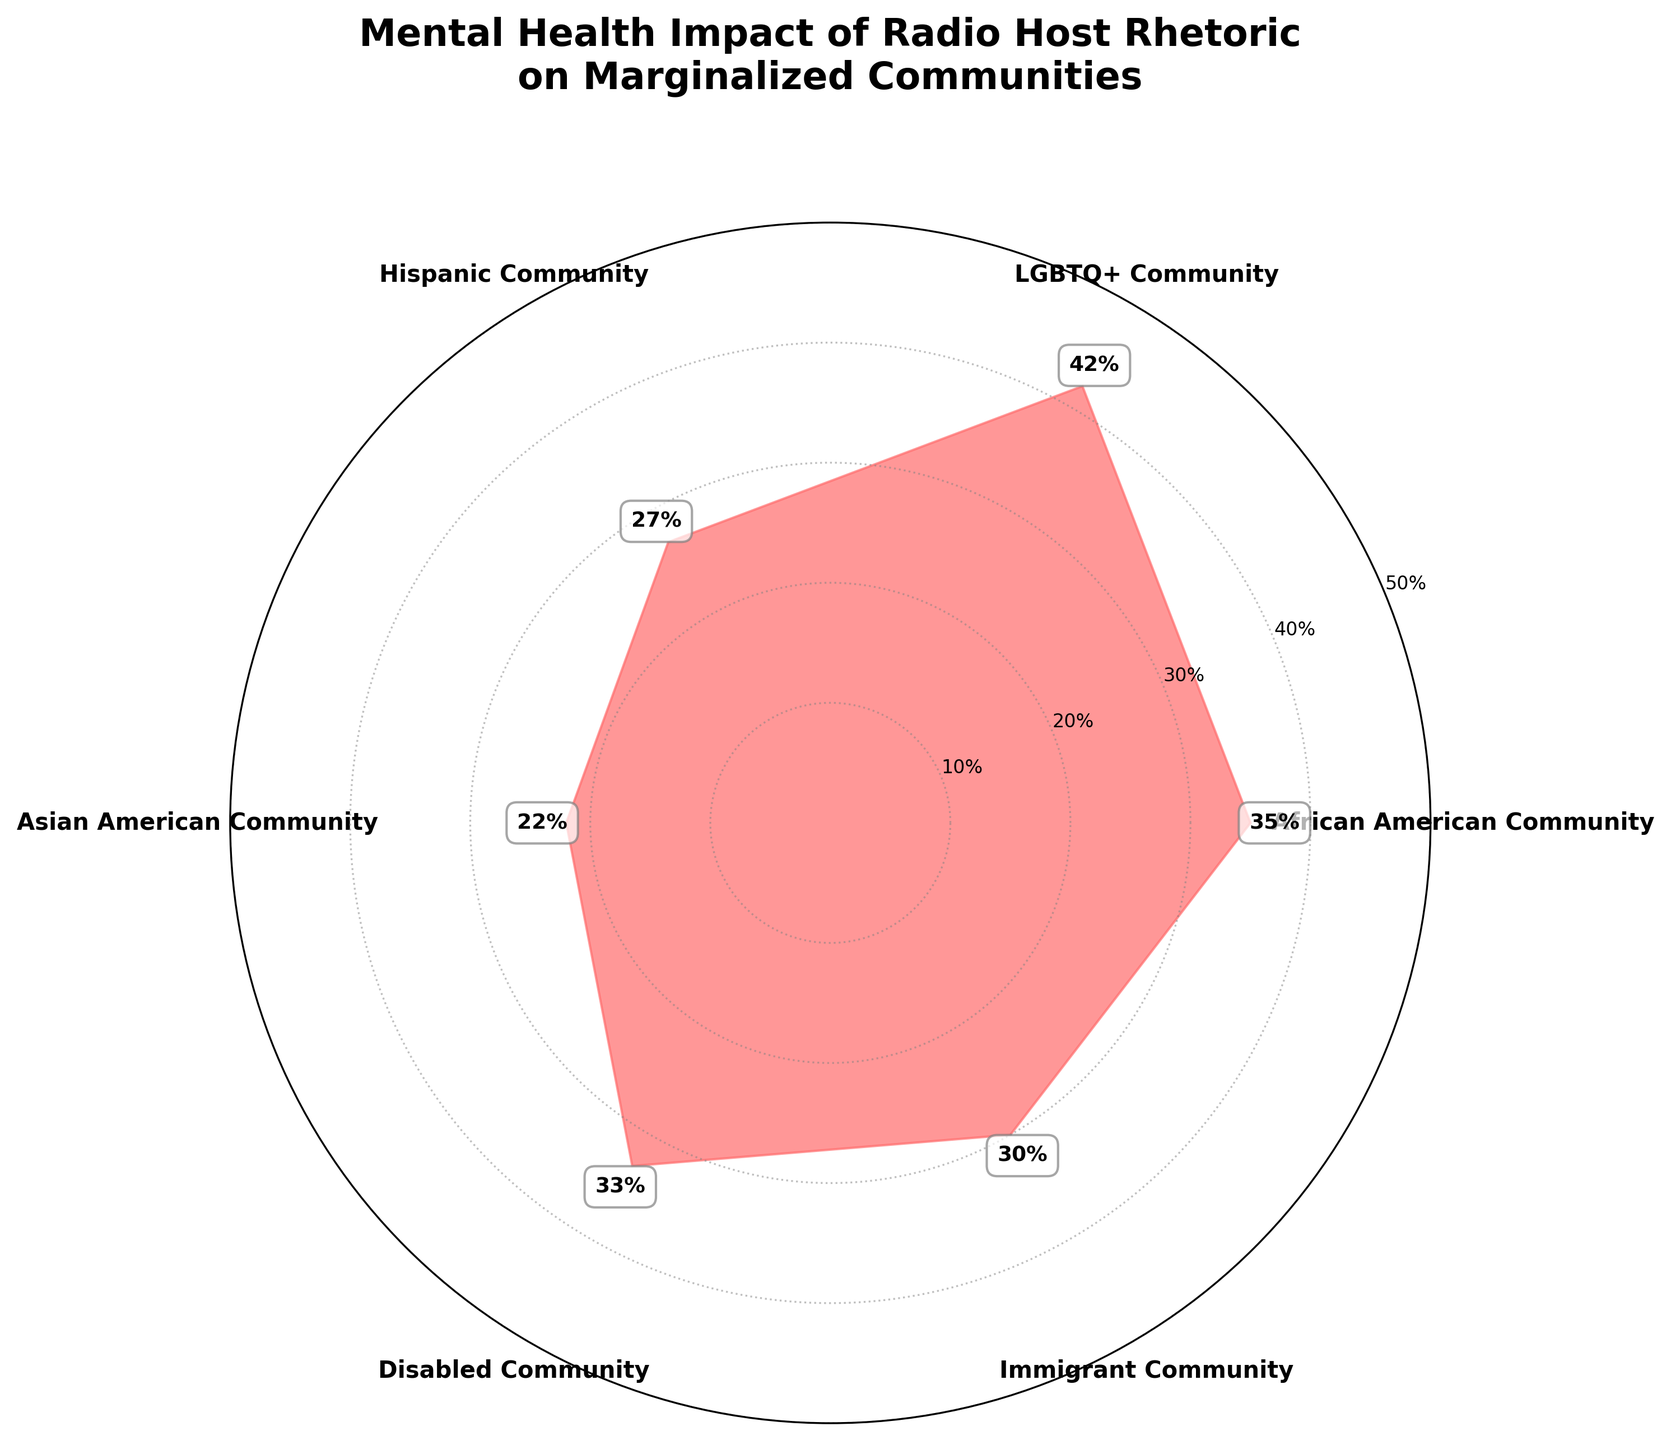What is the title of the plot? The title of the plot is located at the top and usually summarizes the main insight of the chart. In this case, the title reads "Mental Health Impact of Radio Host Rhetoric on Marginalized Communities".
Answer: "Mental Health Impact of Radio Host Rhetoric on Marginalized Communities" How many marginalized community categories are represented in the chart? Count the number of unique categories around the circle. There are six categories represented: African American Community, LGBTQ+ Community, Hispanic Community, Asian American Community, Disabled Community, and Immigrant Community.
Answer: 6 Which marginalized community reports the highest percentage of mental health impacts? Locate the segment with the highest value indicated by the length of the filled area. The LGBTQ+ Community reports the highest percentage of mental health impacts, which is 42%.
Answer: LGBTQ+ Community Which marginalized community reports the lowest percentage of mental health impacts? Locate the shortest segment or smallest value indicated by the length of the filled area. The Asian American Community reports the lowest percentage of mental health impacts, which is 22%.
Answer: Asian American Community What is the difference in reported mental health impacts between the LGBTQ+ Community and the Hispanic Community? Identify the percentages for both communities (LGBTQ+ Community: 42%, Hispanic Community: 27%) and subtract the smaller percentage from the larger one. The difference is 42% - 27% = 15%.
Answer: 15% What is the average percentage of mental health impacts reported across all categories? Add up all the percentages and divide by the number of categories. The total is (35 + 42 + 27 + 22 + 33 + 30) = 189. The average is 189 / 6 = 31.5%.
Answer: 31.5% Which two communities are closest in terms of their reported mental health impact percentages? Compare the percentages of each community to find the smallest difference. The African American Community (35%) and Disabled Community (33%) are closest, with a difference of 2%.
Answer: African American Community and Disabled Community What percentage of the Immigrant Community reports mental health impacts linked to exposure to specific radio host rhetoric? Identify the percentage for the Immigrant Community from the chart, which is explicitly labeled as 30%.
Answer: 30% In terms of reported mental health impacts, how do the Disabled Community and Asian American Community compare? Identify and compare the percentages of both communities. The Disabled Community reports 33%, while the Asian American Community reports 22%. The Disabled Community has a higher percentage.
Answer: Disabled Community has a higher percentage What can you infer about the mental health impacts of radio host rhetoric on the overall population of marginalized communities? Consider the title and the spread of data points. The chart indicates that significant portions of various marginalized communities report adverse mental health impacts, with percentages ranging from 22% to 42%, suggesting widespread concern across different groups.
Answer: Significant mental health impacts across communities 